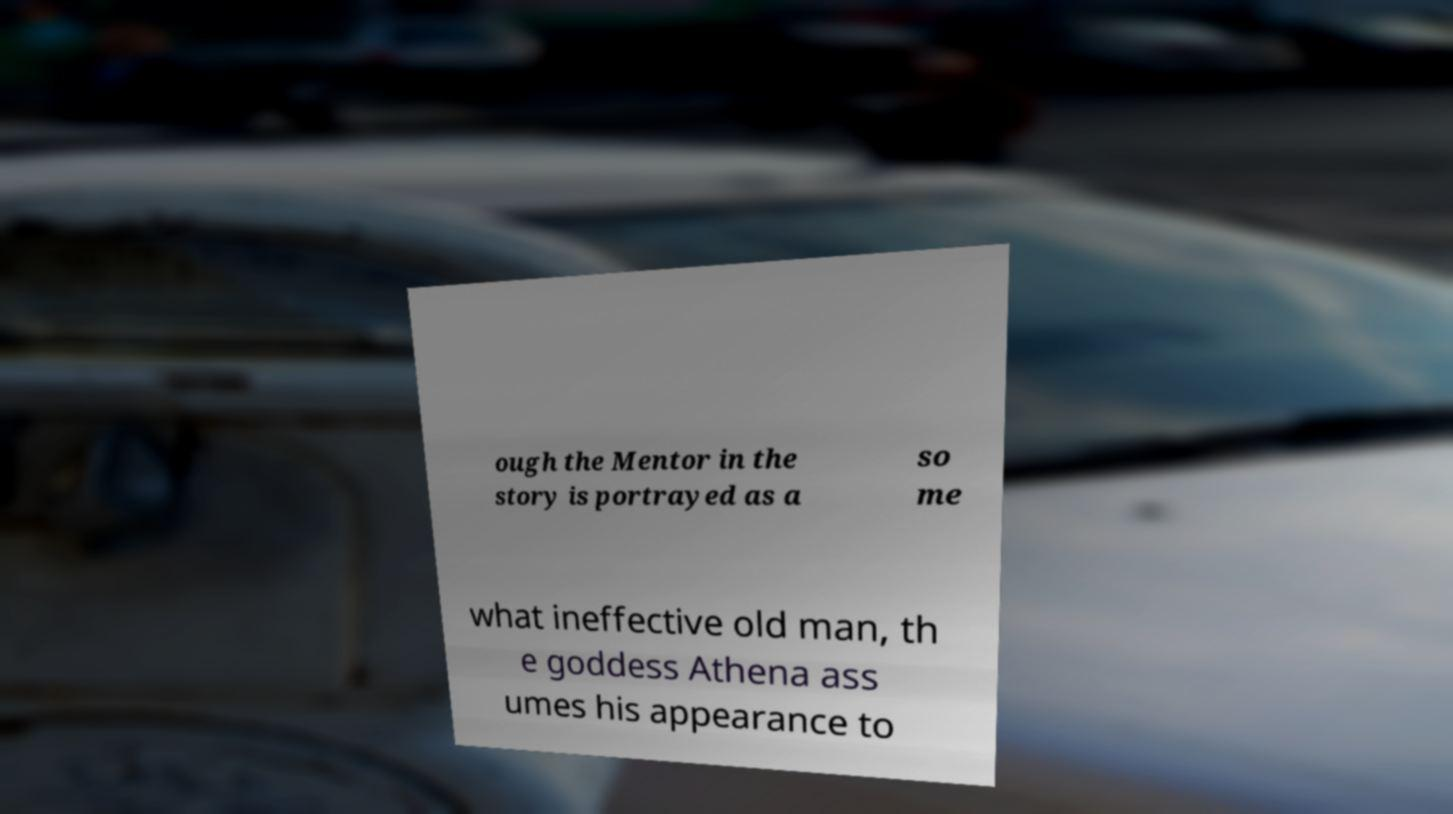I need the written content from this picture converted into text. Can you do that? ough the Mentor in the story is portrayed as a so me what ineffective old man, th e goddess Athena ass umes his appearance to 